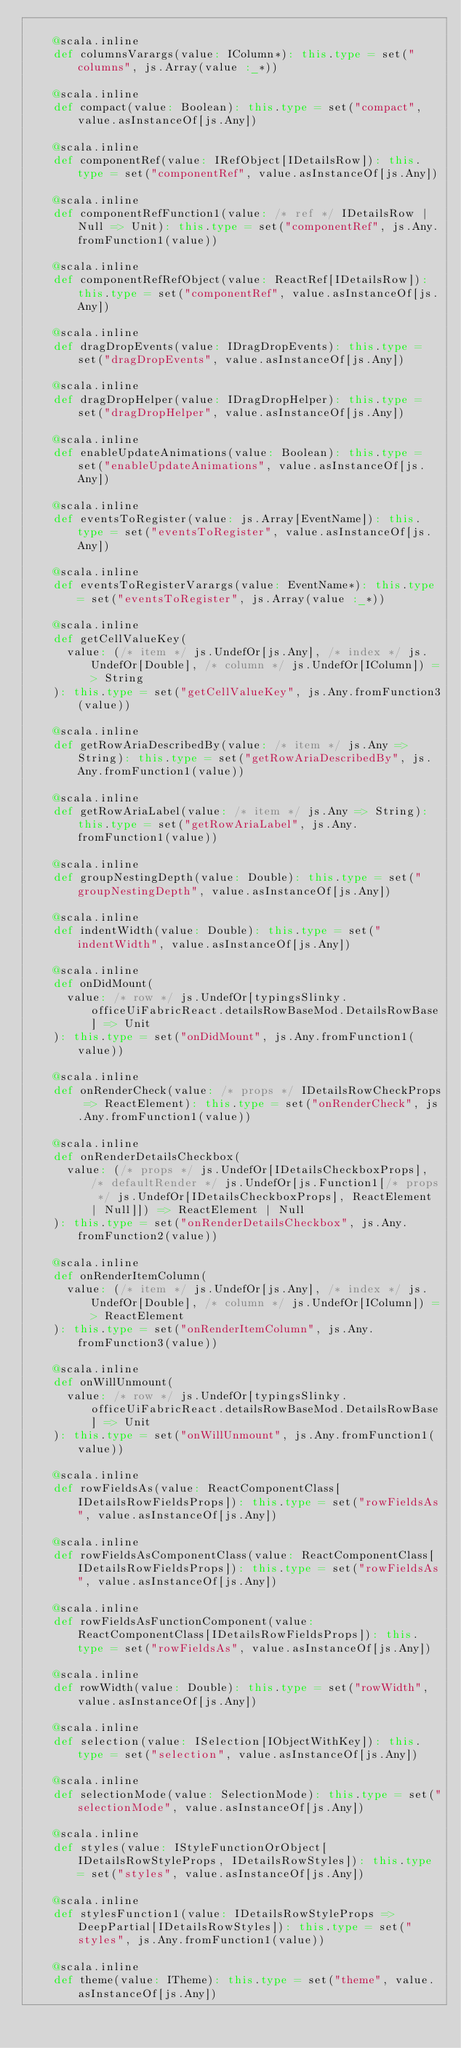Convert code to text. <code><loc_0><loc_0><loc_500><loc_500><_Scala_>    
    @scala.inline
    def columnsVarargs(value: IColumn*): this.type = set("columns", js.Array(value :_*))
    
    @scala.inline
    def compact(value: Boolean): this.type = set("compact", value.asInstanceOf[js.Any])
    
    @scala.inline
    def componentRef(value: IRefObject[IDetailsRow]): this.type = set("componentRef", value.asInstanceOf[js.Any])
    
    @scala.inline
    def componentRefFunction1(value: /* ref */ IDetailsRow | Null => Unit): this.type = set("componentRef", js.Any.fromFunction1(value))
    
    @scala.inline
    def componentRefRefObject(value: ReactRef[IDetailsRow]): this.type = set("componentRef", value.asInstanceOf[js.Any])
    
    @scala.inline
    def dragDropEvents(value: IDragDropEvents): this.type = set("dragDropEvents", value.asInstanceOf[js.Any])
    
    @scala.inline
    def dragDropHelper(value: IDragDropHelper): this.type = set("dragDropHelper", value.asInstanceOf[js.Any])
    
    @scala.inline
    def enableUpdateAnimations(value: Boolean): this.type = set("enableUpdateAnimations", value.asInstanceOf[js.Any])
    
    @scala.inline
    def eventsToRegister(value: js.Array[EventName]): this.type = set("eventsToRegister", value.asInstanceOf[js.Any])
    
    @scala.inline
    def eventsToRegisterVarargs(value: EventName*): this.type = set("eventsToRegister", js.Array(value :_*))
    
    @scala.inline
    def getCellValueKey(
      value: (/* item */ js.UndefOr[js.Any], /* index */ js.UndefOr[Double], /* column */ js.UndefOr[IColumn]) => String
    ): this.type = set("getCellValueKey", js.Any.fromFunction3(value))
    
    @scala.inline
    def getRowAriaDescribedBy(value: /* item */ js.Any => String): this.type = set("getRowAriaDescribedBy", js.Any.fromFunction1(value))
    
    @scala.inline
    def getRowAriaLabel(value: /* item */ js.Any => String): this.type = set("getRowAriaLabel", js.Any.fromFunction1(value))
    
    @scala.inline
    def groupNestingDepth(value: Double): this.type = set("groupNestingDepth", value.asInstanceOf[js.Any])
    
    @scala.inline
    def indentWidth(value: Double): this.type = set("indentWidth", value.asInstanceOf[js.Any])
    
    @scala.inline
    def onDidMount(
      value: /* row */ js.UndefOr[typingsSlinky.officeUiFabricReact.detailsRowBaseMod.DetailsRowBase] => Unit
    ): this.type = set("onDidMount", js.Any.fromFunction1(value))
    
    @scala.inline
    def onRenderCheck(value: /* props */ IDetailsRowCheckProps => ReactElement): this.type = set("onRenderCheck", js.Any.fromFunction1(value))
    
    @scala.inline
    def onRenderDetailsCheckbox(
      value: (/* props */ js.UndefOr[IDetailsCheckboxProps], /* defaultRender */ js.UndefOr[js.Function1[/* props */ js.UndefOr[IDetailsCheckboxProps], ReactElement | Null]]) => ReactElement | Null
    ): this.type = set("onRenderDetailsCheckbox", js.Any.fromFunction2(value))
    
    @scala.inline
    def onRenderItemColumn(
      value: (/* item */ js.UndefOr[js.Any], /* index */ js.UndefOr[Double], /* column */ js.UndefOr[IColumn]) => ReactElement
    ): this.type = set("onRenderItemColumn", js.Any.fromFunction3(value))
    
    @scala.inline
    def onWillUnmount(
      value: /* row */ js.UndefOr[typingsSlinky.officeUiFabricReact.detailsRowBaseMod.DetailsRowBase] => Unit
    ): this.type = set("onWillUnmount", js.Any.fromFunction1(value))
    
    @scala.inline
    def rowFieldsAs(value: ReactComponentClass[IDetailsRowFieldsProps]): this.type = set("rowFieldsAs", value.asInstanceOf[js.Any])
    
    @scala.inline
    def rowFieldsAsComponentClass(value: ReactComponentClass[IDetailsRowFieldsProps]): this.type = set("rowFieldsAs", value.asInstanceOf[js.Any])
    
    @scala.inline
    def rowFieldsAsFunctionComponent(value: ReactComponentClass[IDetailsRowFieldsProps]): this.type = set("rowFieldsAs", value.asInstanceOf[js.Any])
    
    @scala.inline
    def rowWidth(value: Double): this.type = set("rowWidth", value.asInstanceOf[js.Any])
    
    @scala.inline
    def selection(value: ISelection[IObjectWithKey]): this.type = set("selection", value.asInstanceOf[js.Any])
    
    @scala.inline
    def selectionMode(value: SelectionMode): this.type = set("selectionMode", value.asInstanceOf[js.Any])
    
    @scala.inline
    def styles(value: IStyleFunctionOrObject[IDetailsRowStyleProps, IDetailsRowStyles]): this.type = set("styles", value.asInstanceOf[js.Any])
    
    @scala.inline
    def stylesFunction1(value: IDetailsRowStyleProps => DeepPartial[IDetailsRowStyles]): this.type = set("styles", js.Any.fromFunction1(value))
    
    @scala.inline
    def theme(value: ITheme): this.type = set("theme", value.asInstanceOf[js.Any])
    </code> 